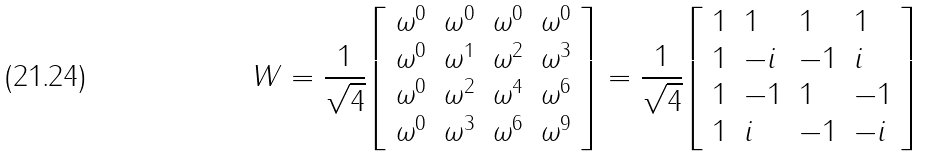Convert formula to latex. <formula><loc_0><loc_0><loc_500><loc_500>W = { \frac { 1 } { \sqrt { 4 } } } { \left [ \begin{array} { l l l l } { \omega ^ { 0 } } & { \omega ^ { 0 } } & { \omega ^ { 0 } } & { \omega ^ { 0 } } \\ { \omega ^ { 0 } } & { \omega ^ { 1 } } & { \omega ^ { 2 } } & { \omega ^ { 3 } } \\ { \omega ^ { 0 } } & { \omega ^ { 2 } } & { \omega ^ { 4 } } & { \omega ^ { 6 } } \\ { \omega ^ { 0 } } & { \omega ^ { 3 } } & { \omega ^ { 6 } } & { \omega ^ { 9 } } \end{array} \right ] } = { \frac { 1 } { \sqrt { 4 } } } { \left [ \begin{array} { l l l l } { 1 } & { 1 } & { 1 } & { 1 } \\ { 1 } & { - i } & { - 1 } & { i } \\ { 1 } & { - 1 } & { 1 } & { - 1 } \\ { 1 } & { i } & { - 1 } & { - i } \end{array} \right ] }</formula> 